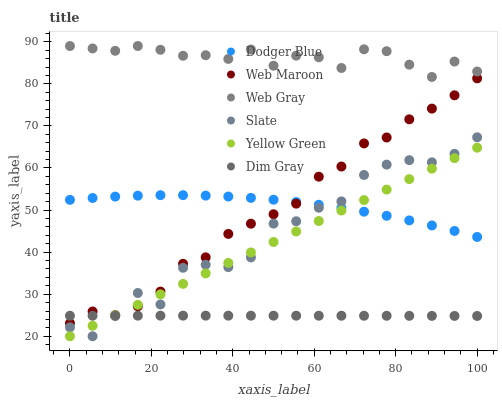Does Dim Gray have the minimum area under the curve?
Answer yes or no. Yes. Does Web Gray have the maximum area under the curve?
Answer yes or no. Yes. Does Yellow Green have the minimum area under the curve?
Answer yes or no. No. Does Yellow Green have the maximum area under the curve?
Answer yes or no. No. Is Yellow Green the smoothest?
Answer yes or no. Yes. Is Slate the roughest?
Answer yes or no. Yes. Is Slate the smoothest?
Answer yes or no. No. Is Yellow Green the roughest?
Answer yes or no. No. Does Yellow Green have the lowest value?
Answer yes or no. Yes. Does Web Maroon have the lowest value?
Answer yes or no. No. Does Web Gray have the highest value?
Answer yes or no. Yes. Does Yellow Green have the highest value?
Answer yes or no. No. Is Web Maroon less than Web Gray?
Answer yes or no. Yes. Is Web Gray greater than Yellow Green?
Answer yes or no. Yes. Does Web Maroon intersect Yellow Green?
Answer yes or no. Yes. Is Web Maroon less than Yellow Green?
Answer yes or no. No. Is Web Maroon greater than Yellow Green?
Answer yes or no. No. Does Web Maroon intersect Web Gray?
Answer yes or no. No. 